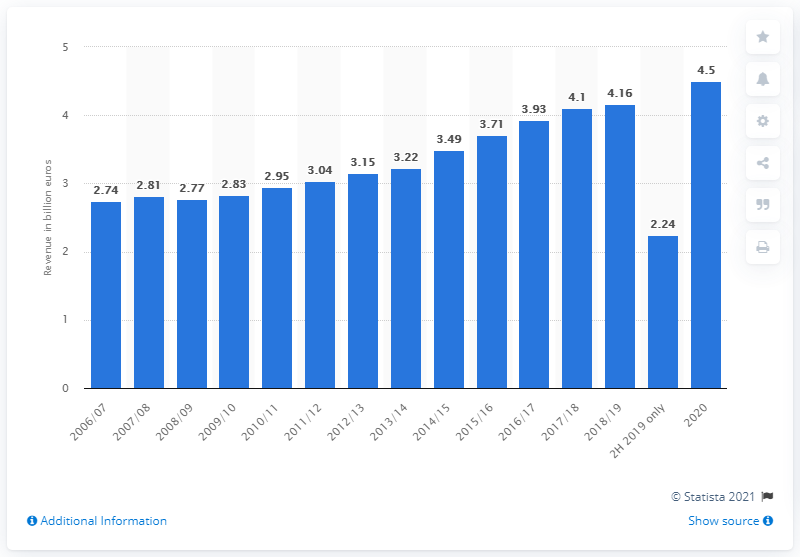Point out several critical features in this image. Miele's revenue for the second half of 2019 was 2.24 billion euros. Miele began reporting its financials according to the calendar year in 2020. Miele generated 4.5 billion euros in revenue during its 2020 financial year. 